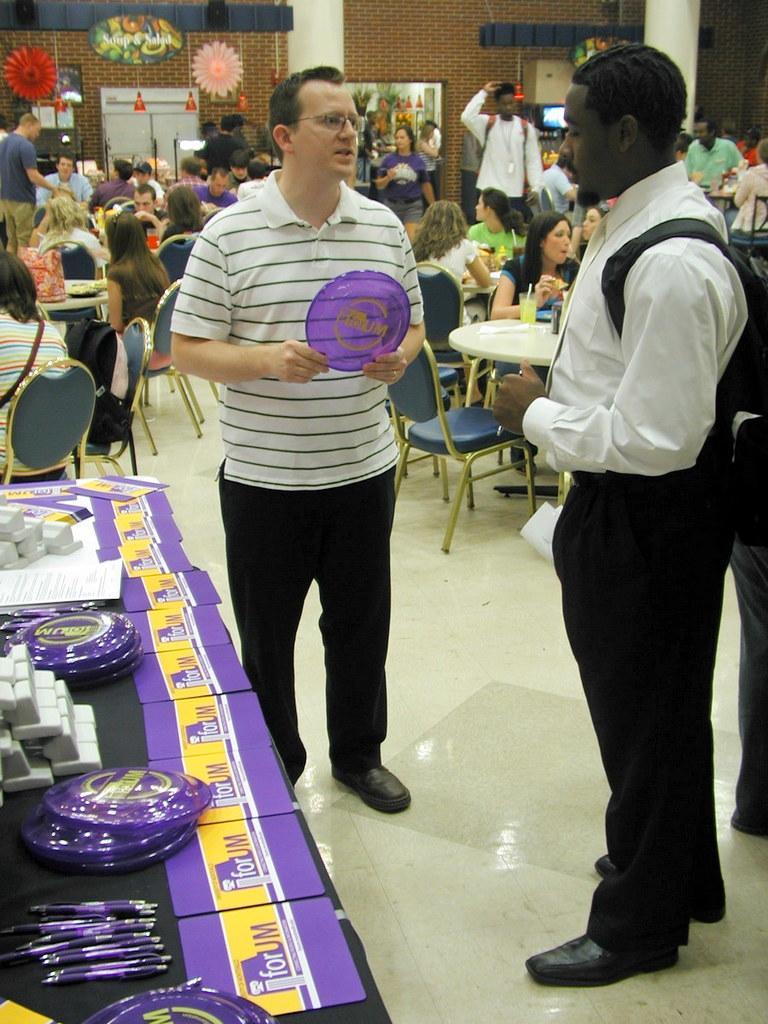How would you summarize this image in a sentence or two? In this picture we can see persons speaking with each other. On their left we have a table with some pens, plates, and some notebooks on it. In the backdrop we find a number of people, we have a brick wall, a photograph on it, and few people sitting and eating. 